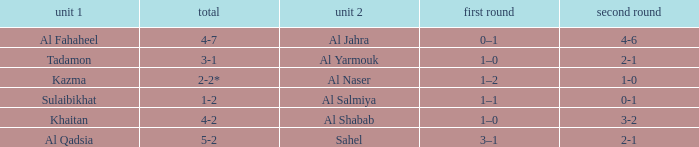What is the name of Team 2 with a Team 1 of Al Qadsia? Sahel. 